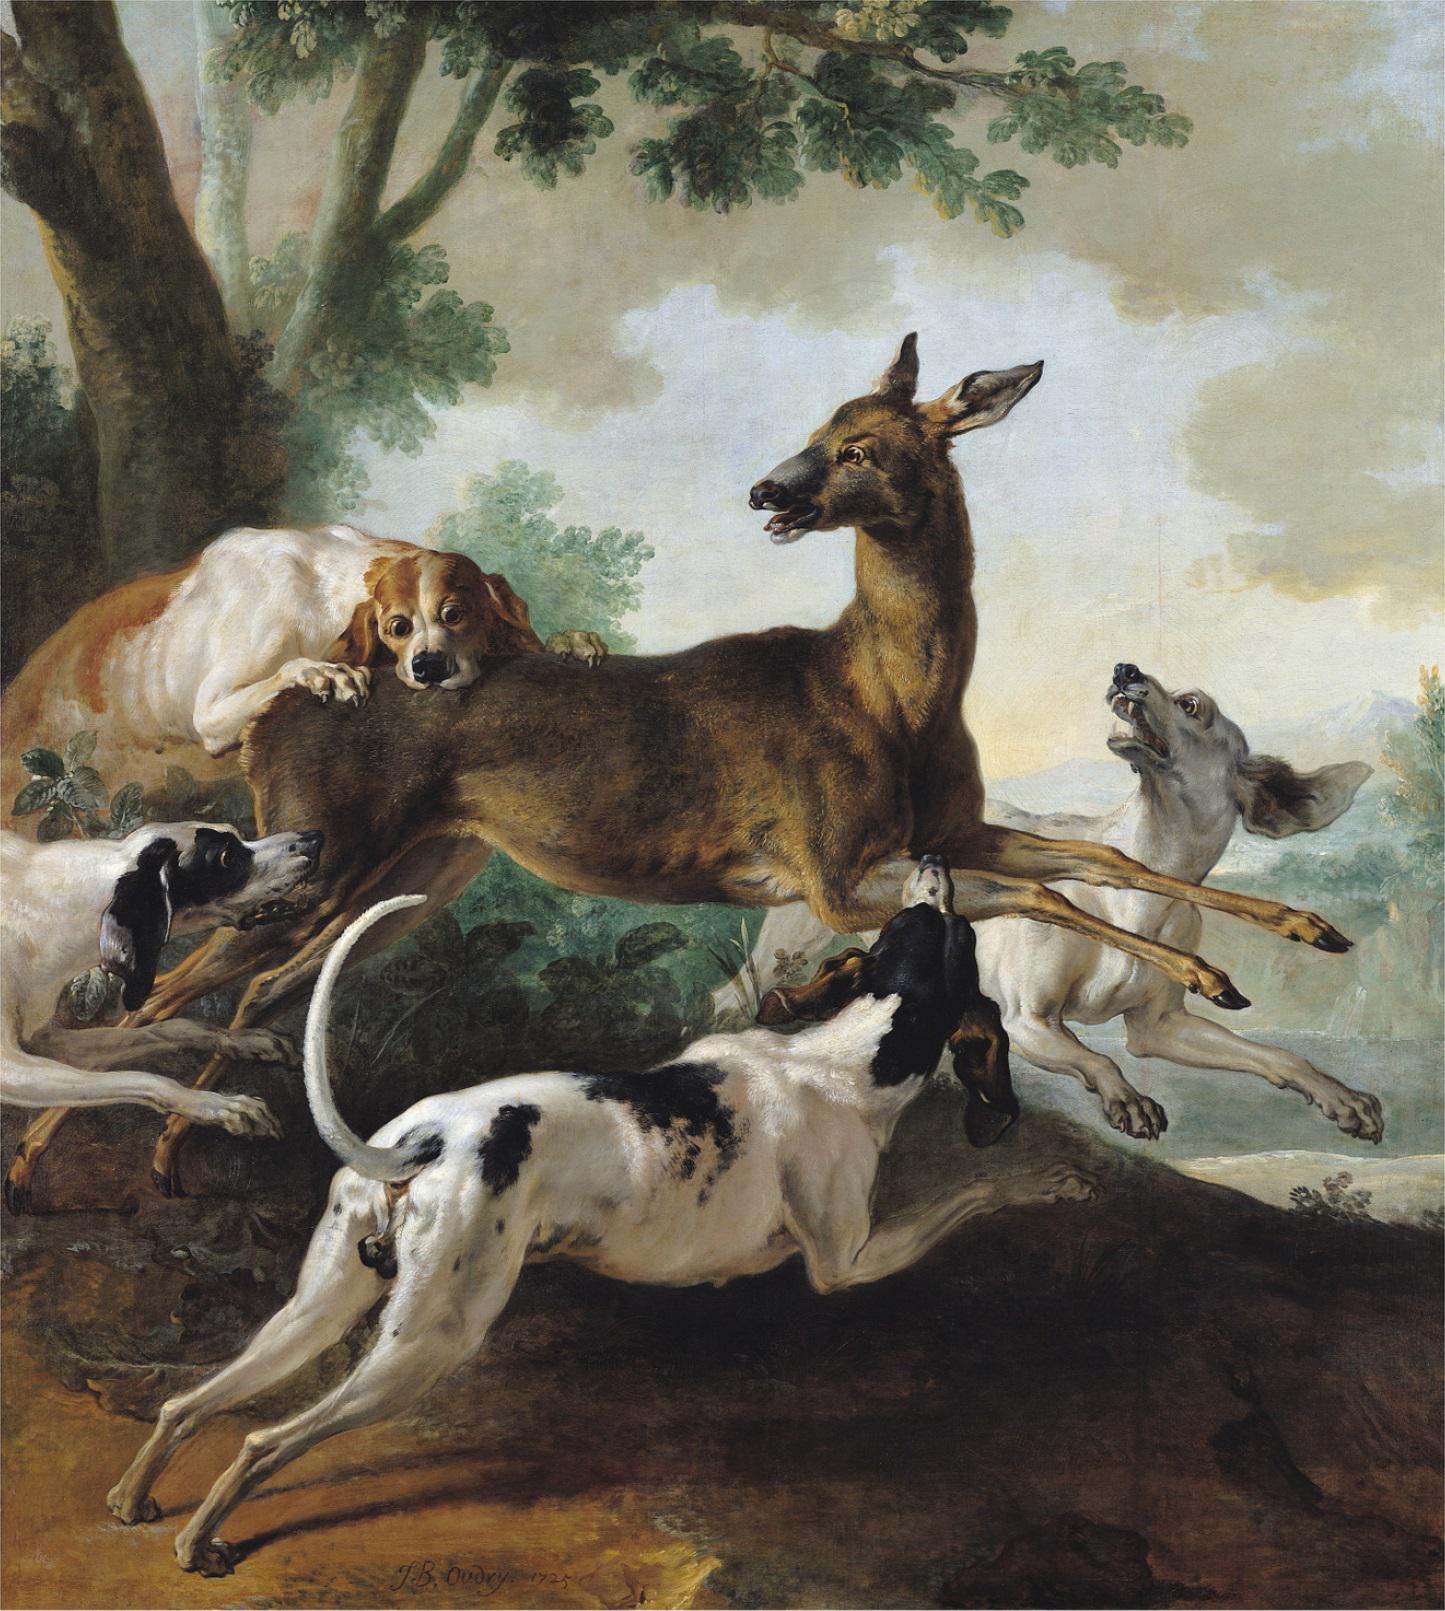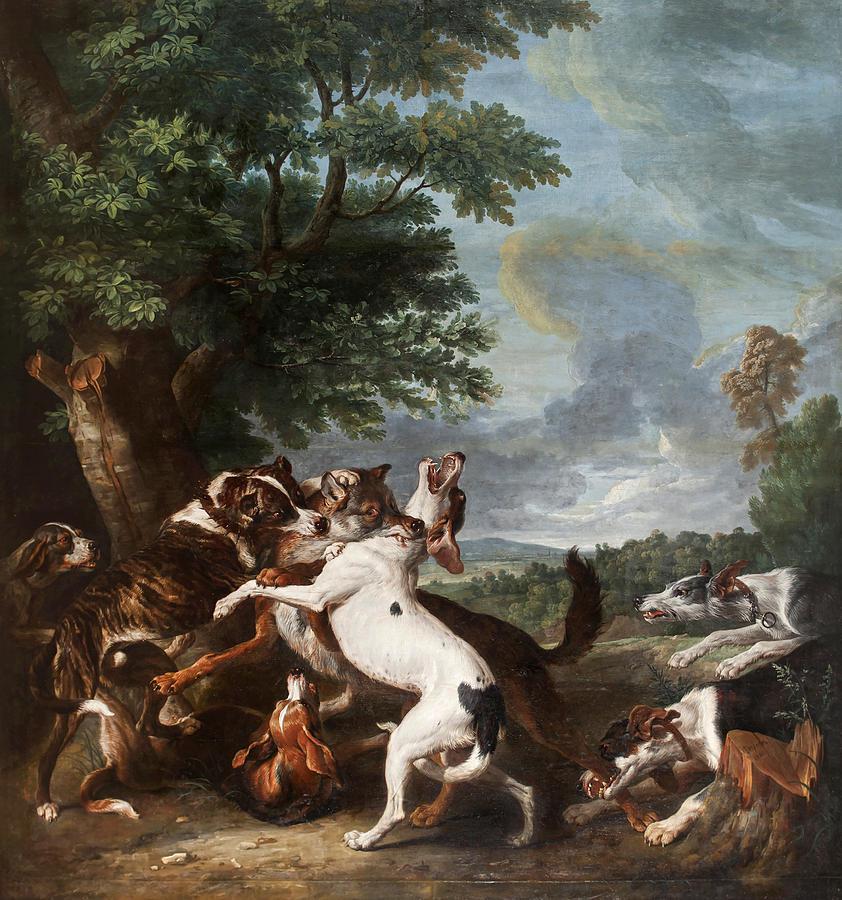The first image is the image on the left, the second image is the image on the right. Analyze the images presented: Is the assertion "There is at least one horse in the same image as a man." valid? Answer yes or no. No. 